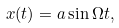<formula> <loc_0><loc_0><loc_500><loc_500>x ( t ) = a \sin { \Omega t } ,</formula> 